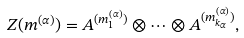<formula> <loc_0><loc_0><loc_500><loc_500>Z ( m ^ { ( \alpha ) } ) = A ^ { ( m _ { 1 } ^ { ( \alpha ) } ) } \otimes \cdots \otimes A ^ { ( m _ { k _ { \alpha } } ^ { ( \alpha ) } ) } ,</formula> 